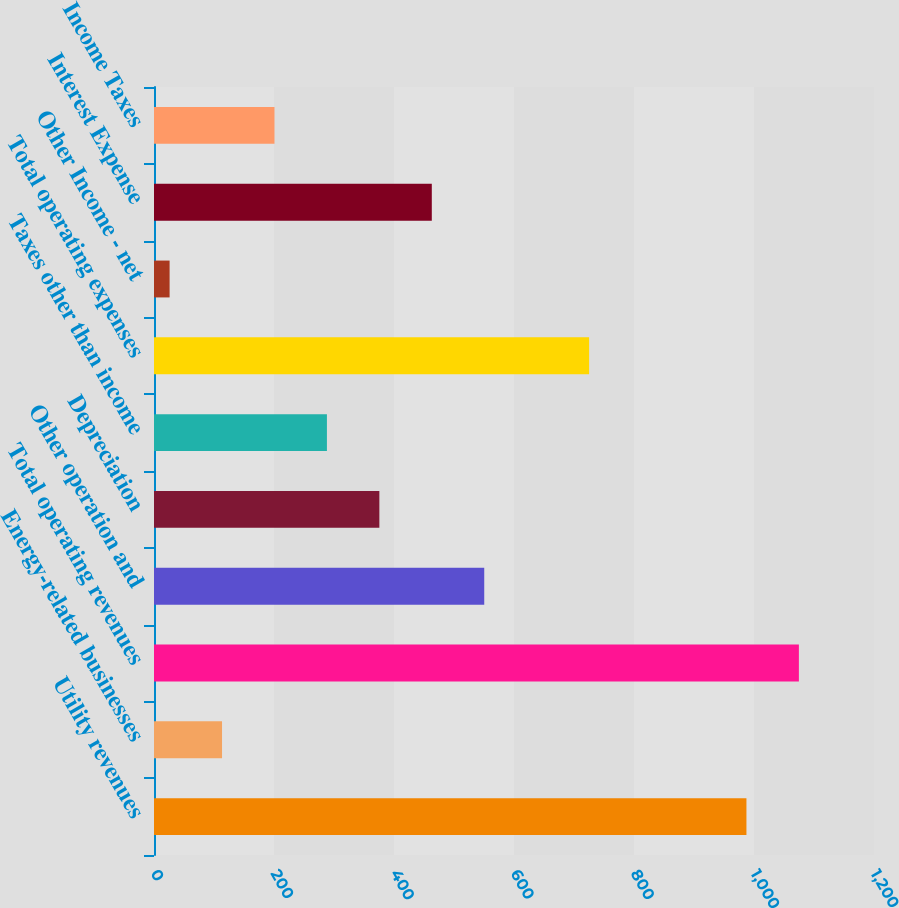<chart> <loc_0><loc_0><loc_500><loc_500><bar_chart><fcel>Utility revenues<fcel>Energy-related businesses<fcel>Total operating revenues<fcel>Other operation and<fcel>Depreciation<fcel>Taxes other than income<fcel>Total operating expenses<fcel>Other Income - net<fcel>Interest Expense<fcel>Income Taxes<nl><fcel>987.4<fcel>113.4<fcel>1074.8<fcel>550.4<fcel>375.6<fcel>288.2<fcel>725.2<fcel>26<fcel>463<fcel>200.8<nl></chart> 